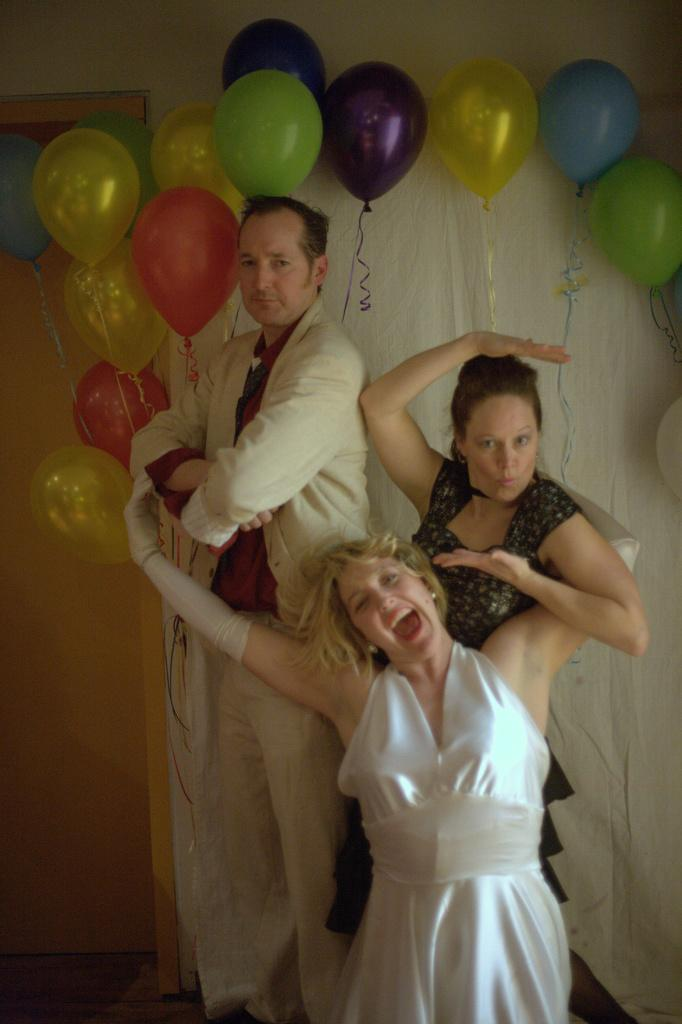What is the main subject in the middle of the image? There is a man standing in the middle of the image. What is the man wearing in the image? The man is wearing a coat and trousers. Can you describe the girl in the image? There is a beautiful girl in the image, and she is wearing a white dress. What can be seen at the top of the image? There are balloons visible at the top of the image. What type of berry is the man requesting from the girl in the image? There is no mention of a berry or a request in the image. The man is simply standing in the middle, and the girl is wearing a white dress. 